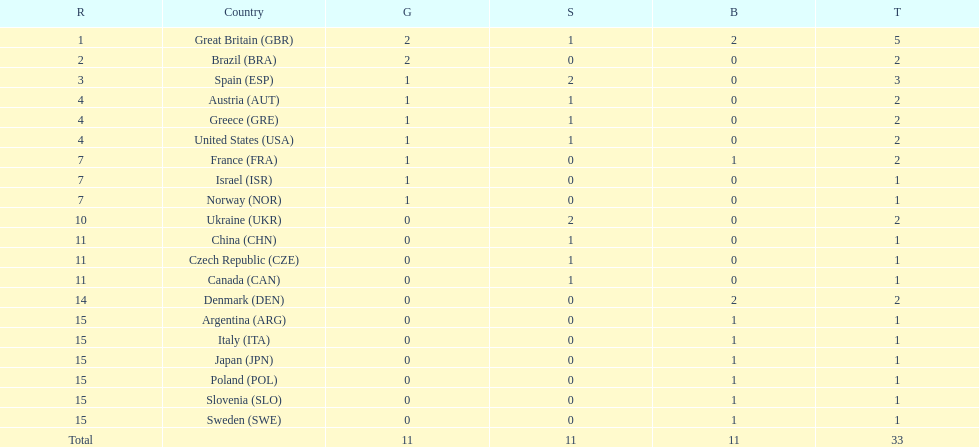How many gold medals did italy receive? 0. 